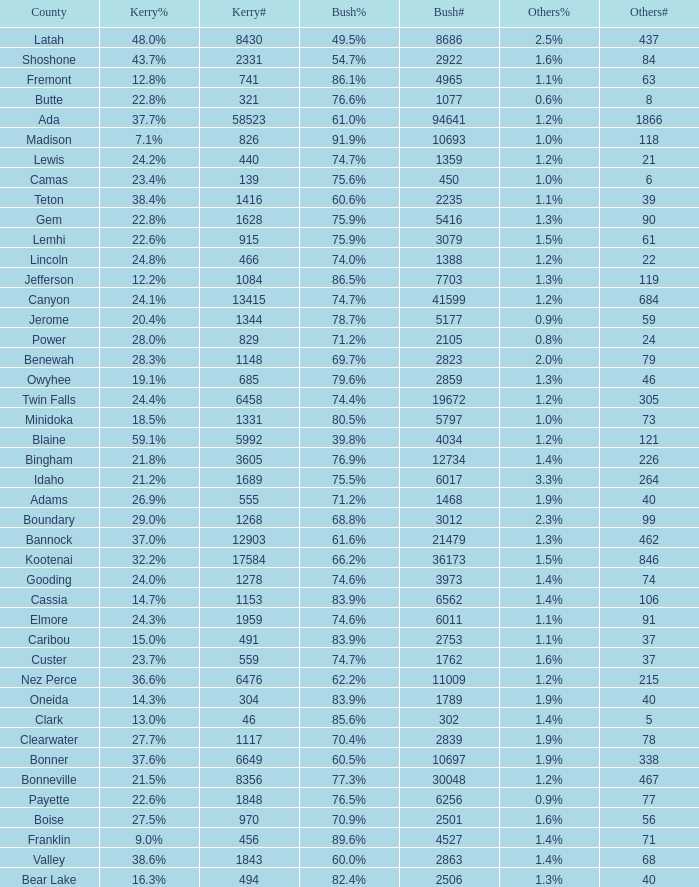What percentage of the votes were for others in the county where 462 people voted that way? 1.3%. 